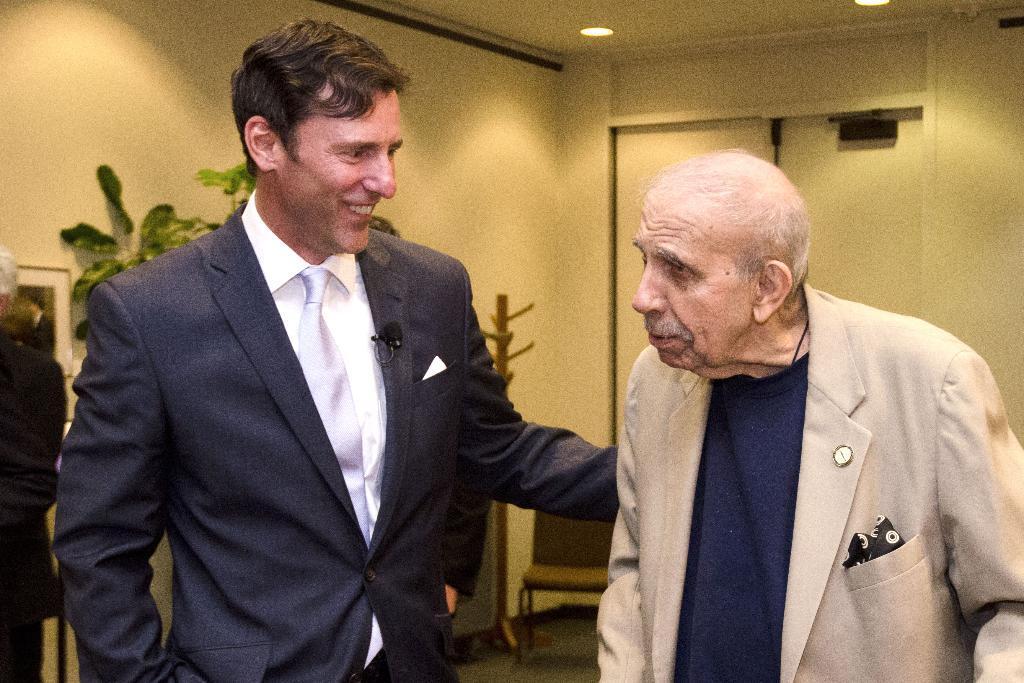Could you give a brief overview of what you see in this image? Here I can see a man and an old man man wearing suits and standing. The man is smiling by looking at the old man. In the background, I can see the wall and few house plants. At the top there are some lights on the roof. On the left side, I can see a person standing. In the background there is a chair on the ground. 